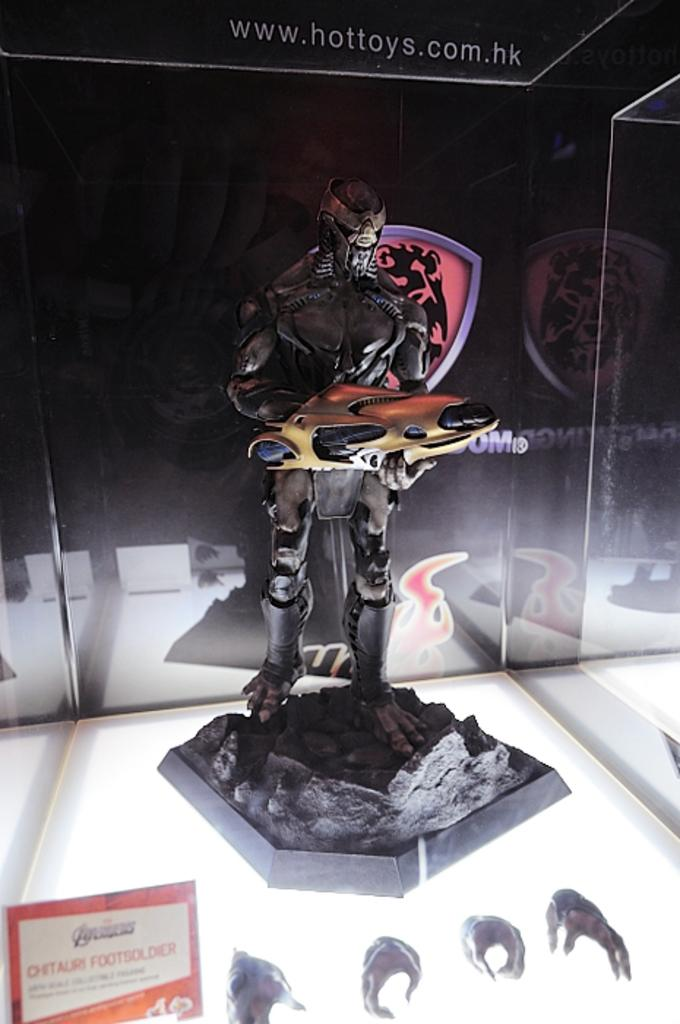What is the main subject of the image? There is a statue of a person in the image. What is the person in the statue holding? The person is holding an object with their hands. What is placed in front of the statue? There is a board in front of the statue, and there are objects in front of the statue as well. What does the statue believe in the image? There is no indication in the image that the statue has any beliefs. 